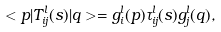<formula> <loc_0><loc_0><loc_500><loc_500>< p | T _ { i j } ^ { l } ( s ) | q > = g _ { i } ^ { l } ( p ) \tau _ { i j } ^ { l } ( s ) g _ { j } ^ { l } ( q ) ,</formula> 